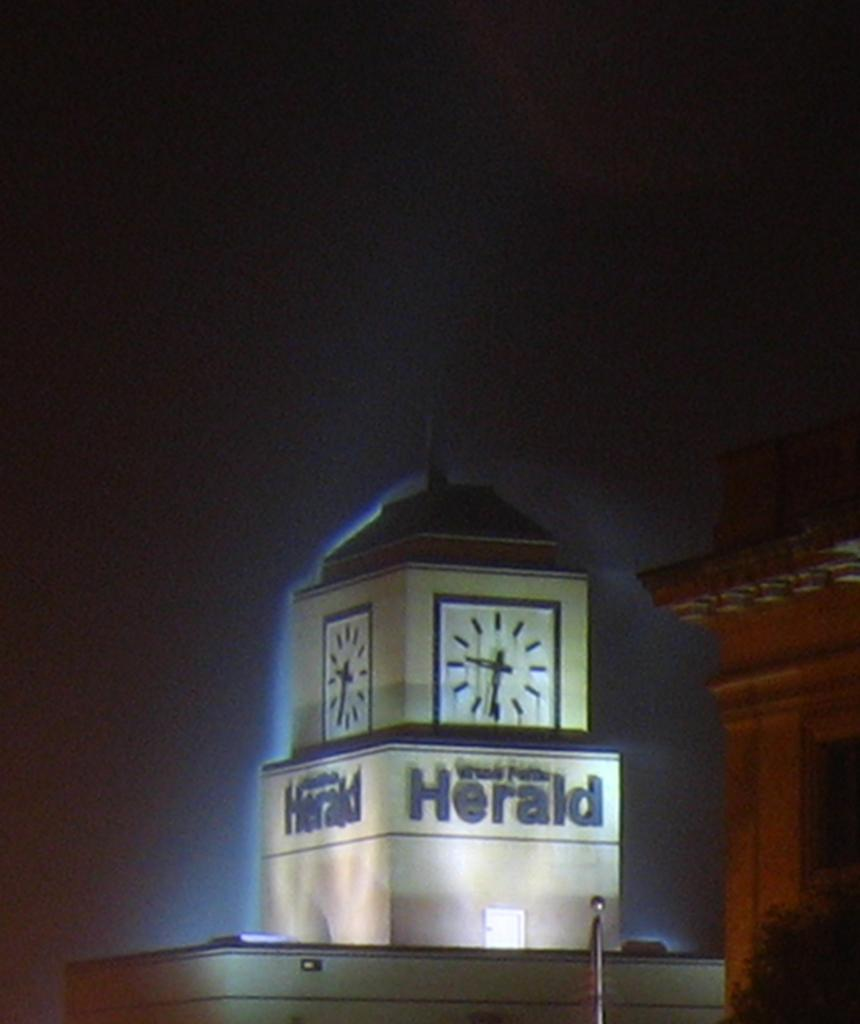<image>
Write a terse but informative summary of the picture. A clock tower says Herald in dark letters. 